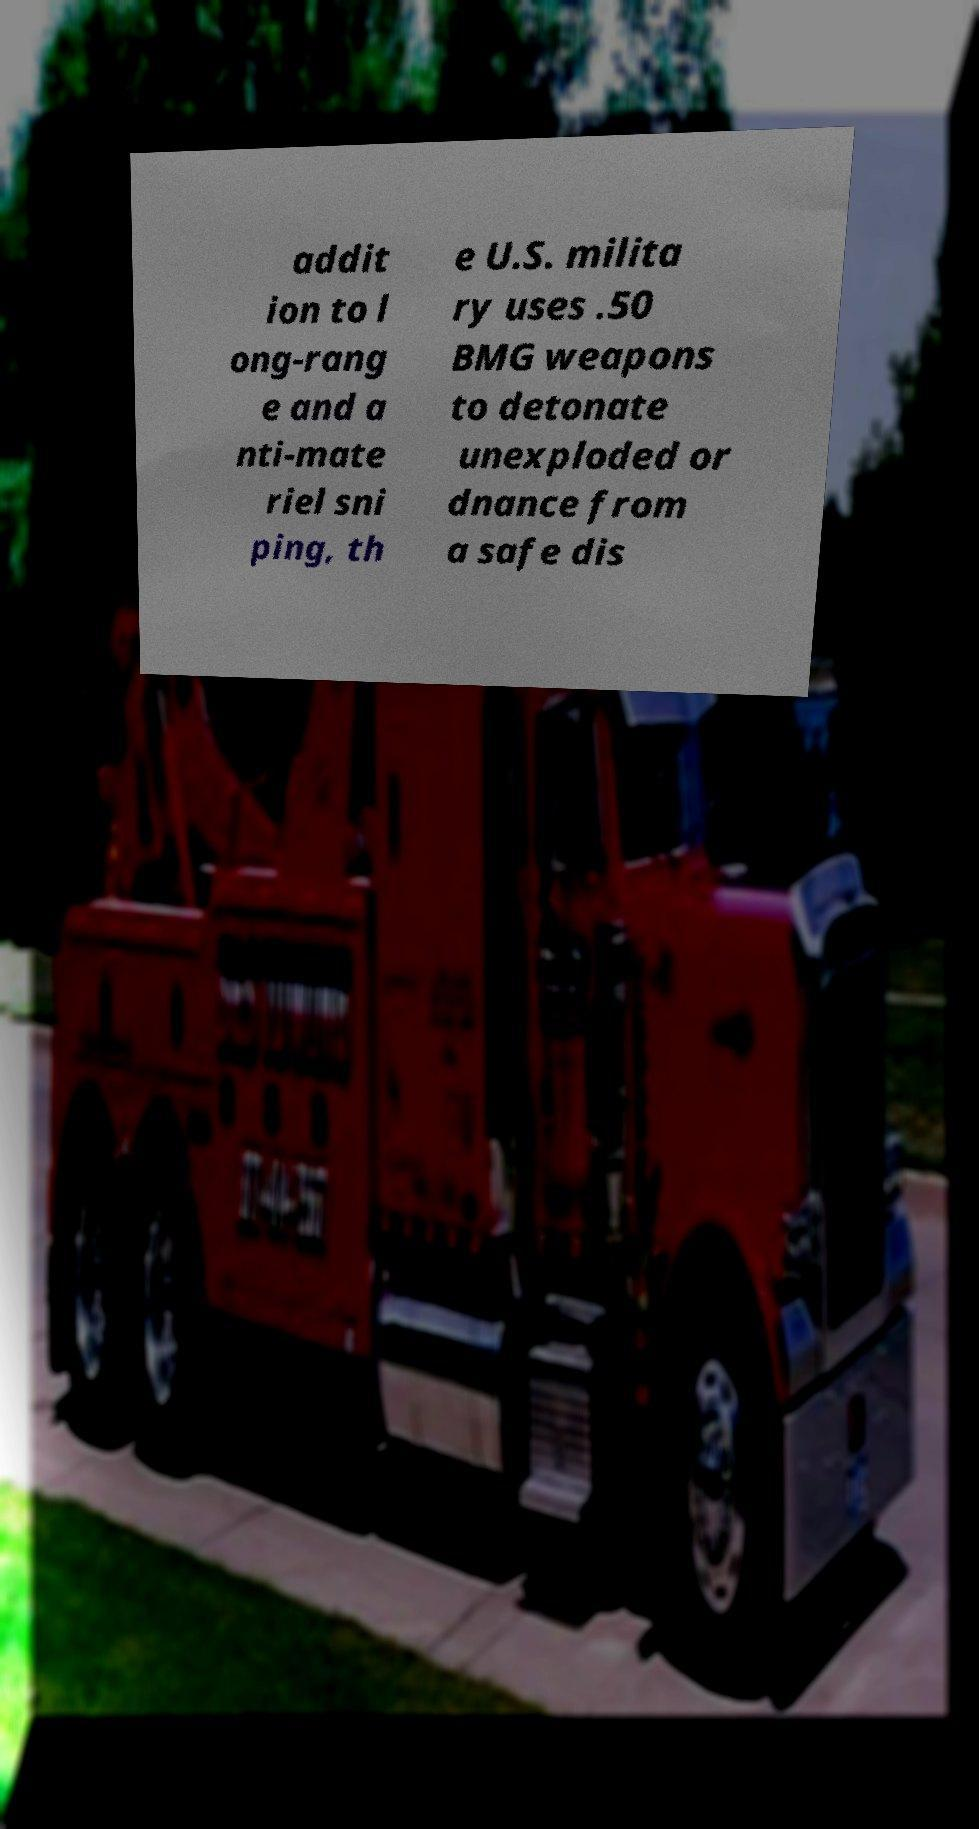Could you assist in decoding the text presented in this image and type it out clearly? addit ion to l ong-rang e and a nti-mate riel sni ping, th e U.S. milita ry uses .50 BMG weapons to detonate unexploded or dnance from a safe dis 